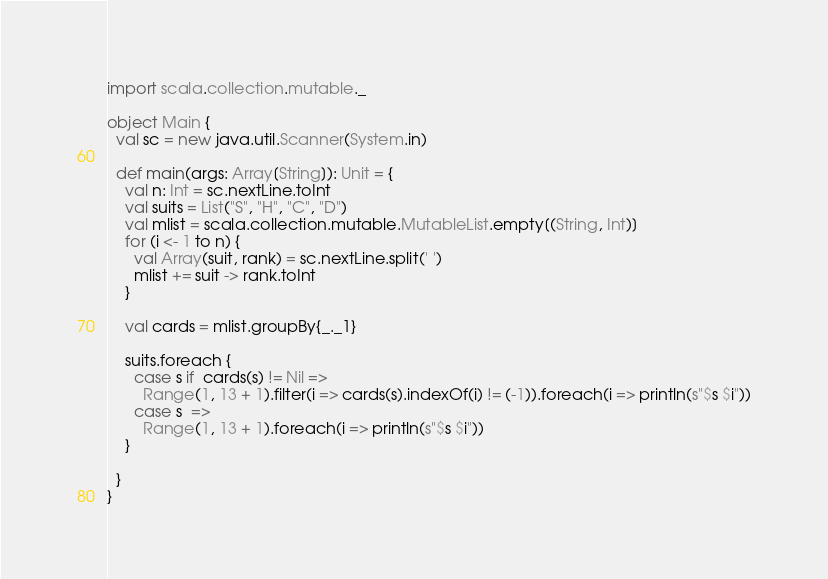<code> <loc_0><loc_0><loc_500><loc_500><_Scala_>import scala.collection.mutable._

object Main {
  val sc = new java.util.Scanner(System.in)

  def main(args: Array[String]): Unit = {
    val n: Int = sc.nextLine.toInt
    val suits = List("S", "H", "C", "D")
    val mlist = scala.collection.mutable.MutableList.empty[(String, Int)]
    for (i <- 1 to n) {
      val Array(suit, rank) = sc.nextLine.split(' ')
      mlist += suit -> rank.toInt
    }

    val cards = mlist.groupBy{_._1}

    suits.foreach {
      case s if  cards(s) != Nil =>
        Range(1, 13 + 1).filter(i => cards(s).indexOf(i) != (-1)).foreach(i => println(s"$s $i"))
      case s  =>
        Range(1, 13 + 1).foreach(i => println(s"$s $i"))
    }

  }
}</code> 